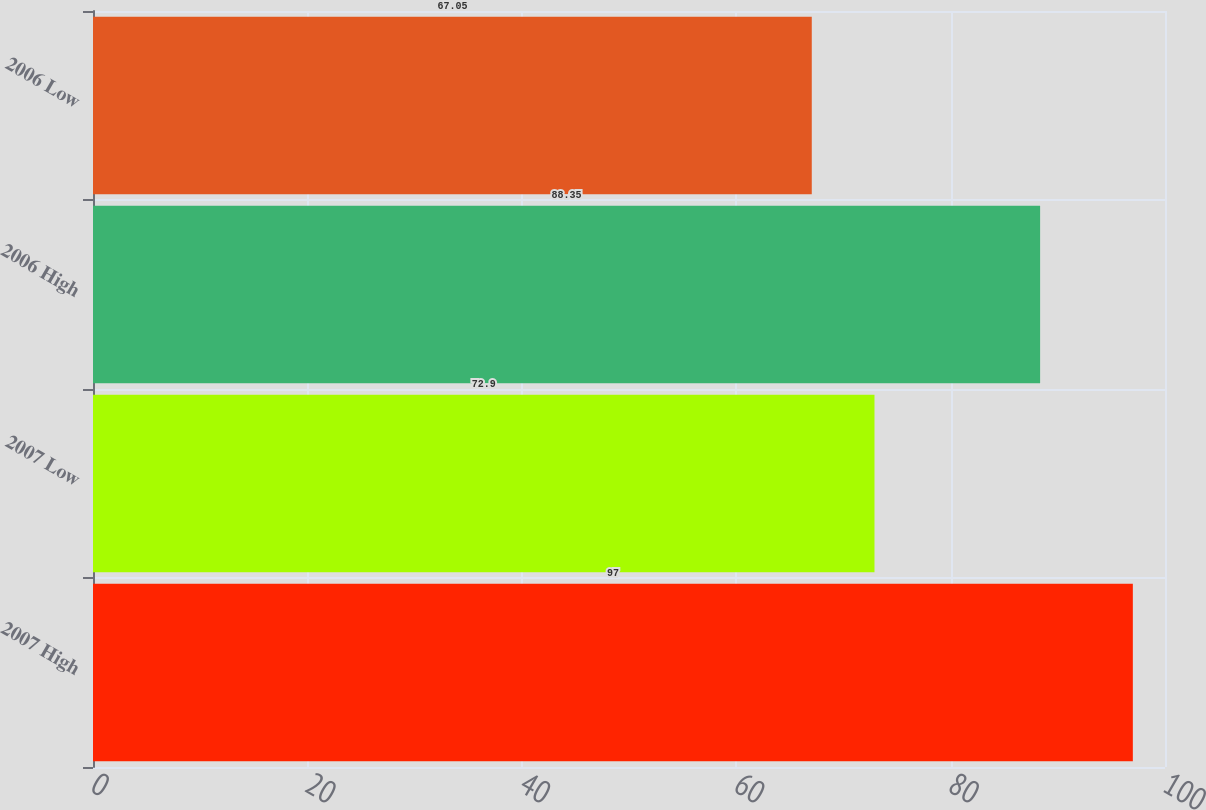Convert chart to OTSL. <chart><loc_0><loc_0><loc_500><loc_500><bar_chart><fcel>2007 High<fcel>2007 Low<fcel>2006 High<fcel>2006 Low<nl><fcel>97<fcel>72.9<fcel>88.35<fcel>67.05<nl></chart> 